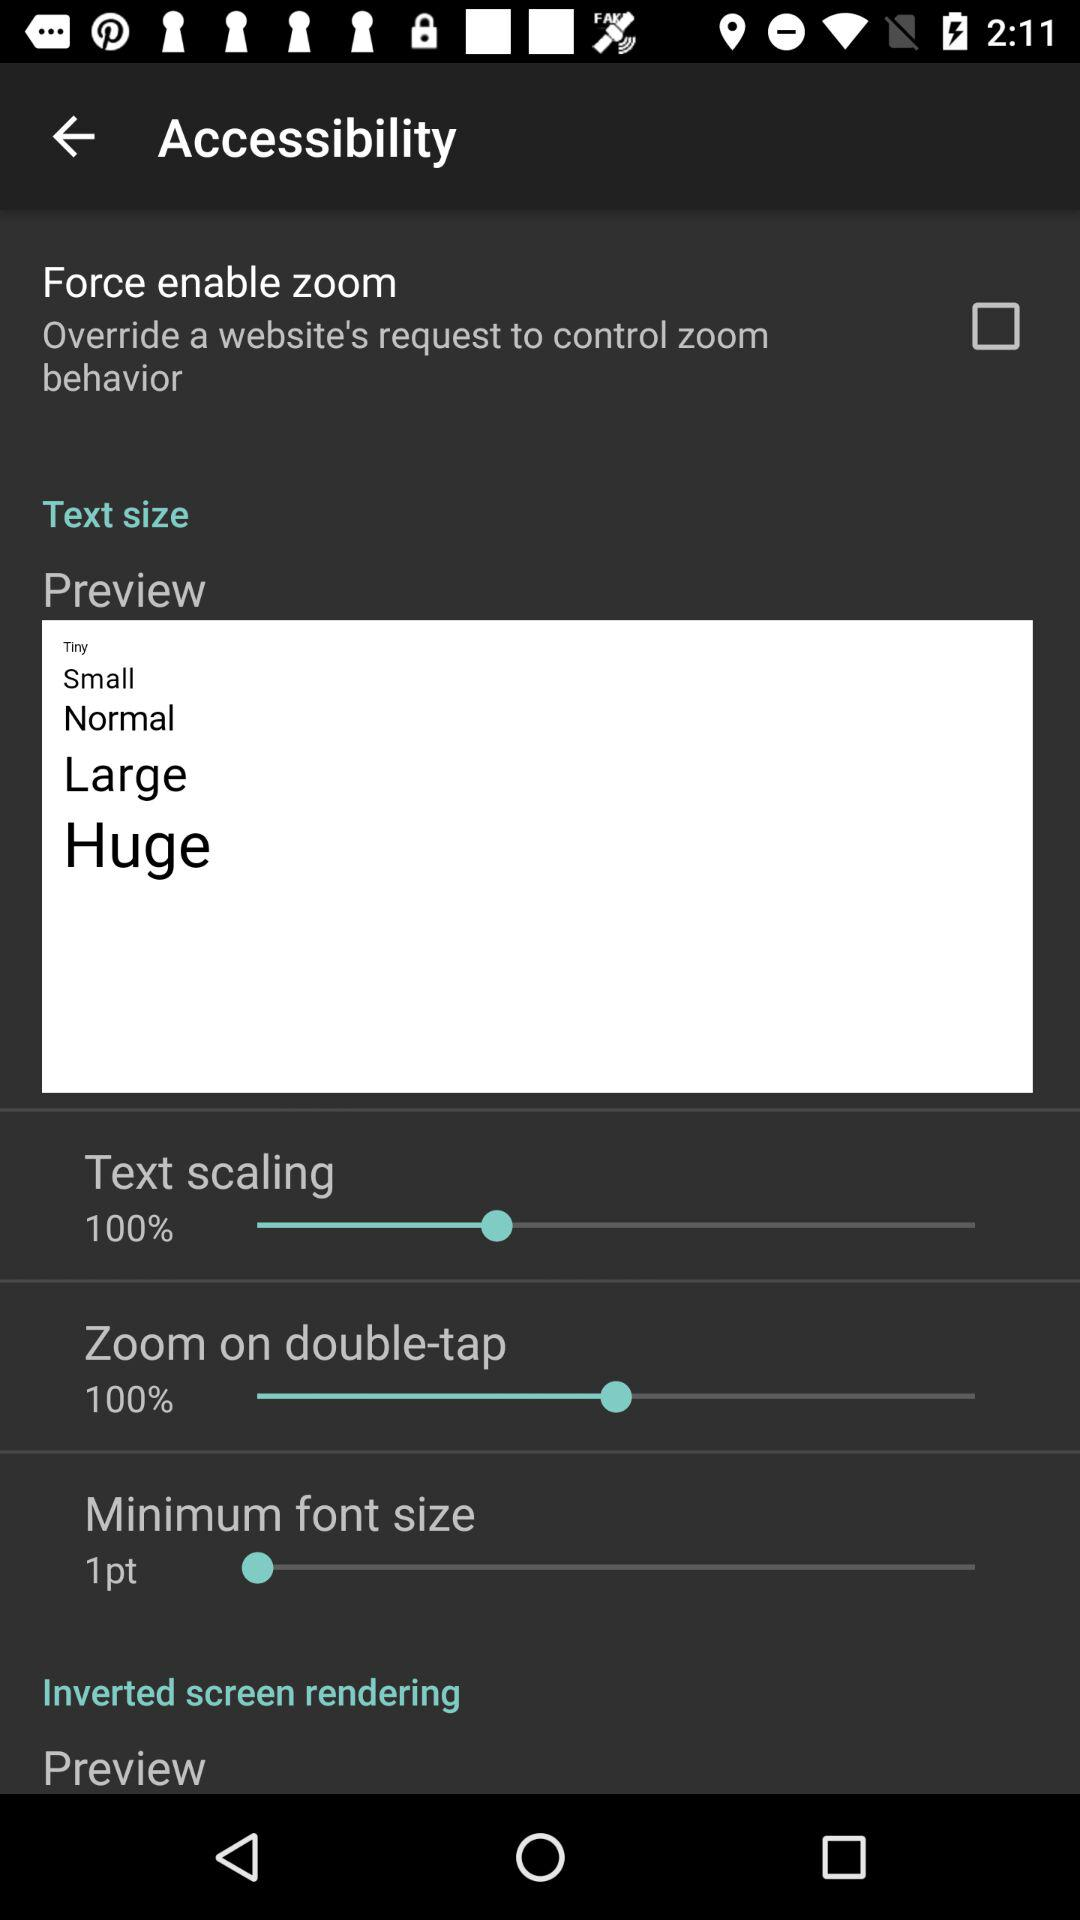What is the minimum text size? The minimum text size is tiny. 